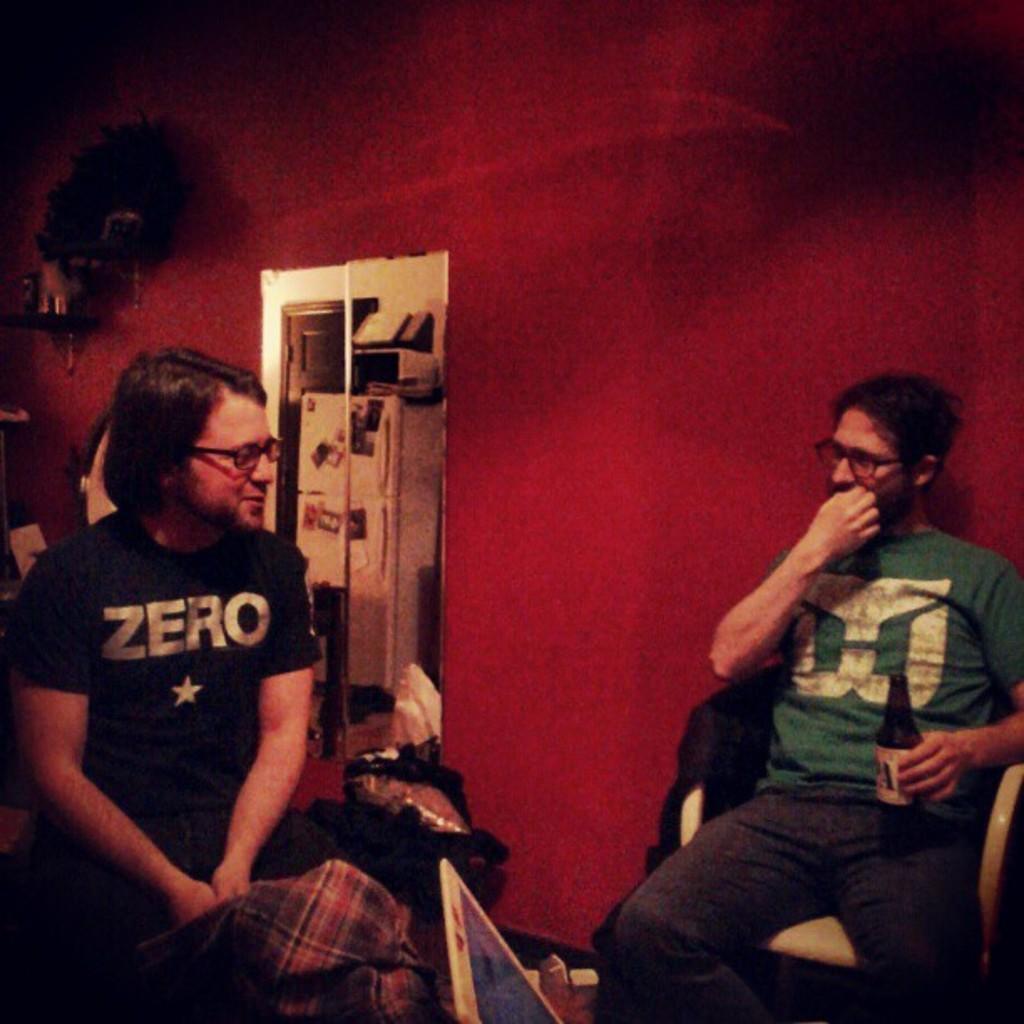Describe this image in one or two sentences. In this image we can see two people sitting and one among them is holding a bottle and looking at a person and sitting on a chair. There is a wall in the background, where we can see some objects on it. To the side of a person we can see some objects. 